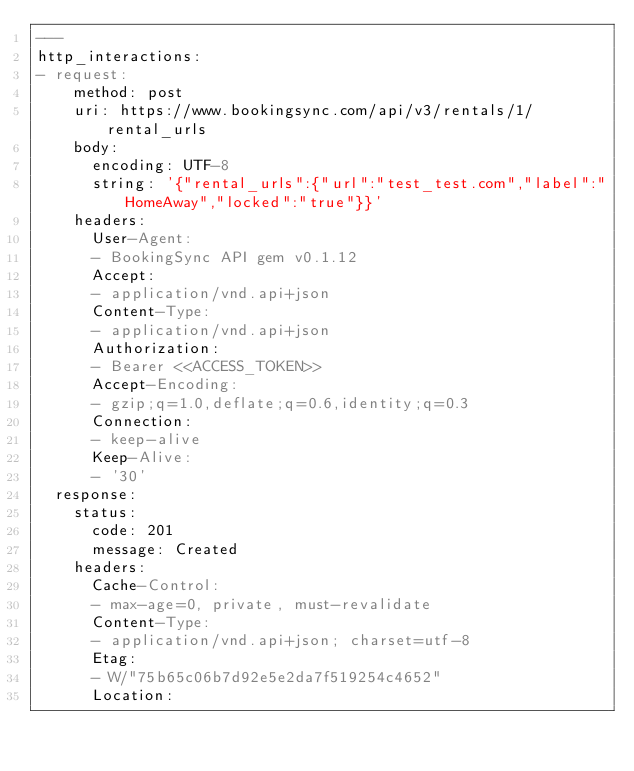Convert code to text. <code><loc_0><loc_0><loc_500><loc_500><_YAML_>---
http_interactions:
- request:
    method: post
    uri: https://www.bookingsync.com/api/v3/rentals/1/rental_urls
    body:
      encoding: UTF-8
      string: '{"rental_urls":{"url":"test_test.com","label":"HomeAway","locked":"true"}}'
    headers:
      User-Agent:
      - BookingSync API gem v0.1.12
      Accept:
      - application/vnd.api+json
      Content-Type:
      - application/vnd.api+json
      Authorization:
      - Bearer <<ACCESS_TOKEN>>
      Accept-Encoding:
      - gzip;q=1.0,deflate;q=0.6,identity;q=0.3
      Connection:
      - keep-alive
      Keep-Alive:
      - '30'
  response:
    status:
      code: 201
      message: Created
    headers:
      Cache-Control:
      - max-age=0, private, must-revalidate
      Content-Type:
      - application/vnd.api+json; charset=utf-8
      Etag:
      - W/"75b65c06b7d92e5e2da7f519254c4652"
      Location:</code> 